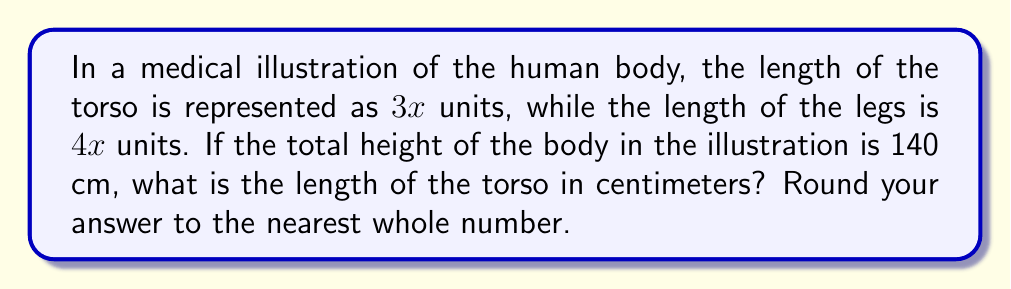Help me with this question. To solve this problem, let's follow these steps:

1) First, we need to understand the proportions given:
   - Torso length = 3x units
   - Leg length = 4x units

2) The total height is the sum of these parts:
   Total height = Torso length + Leg length
   $140 = 3x + 4x$

3) Simplify the right side of the equation:
   $140 = 7x$

4) Solve for x:
   $x = \frac{140}{7} = 20$

5) Now that we know the value of x, we can calculate the torso length:
   Torso length = 3x
   $\text{Torso length} = 3 \cdot 20 = 60$ cm

6) The question asks to round to the nearest whole number, but 60 is already a whole number, so no rounding is necessary.

This proportion (3:4 for torso to legs) is close to the average human body proportions, which is an important consideration in medical illustrations for accurate representation of human anatomy.
Answer: 60 cm 